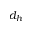<formula> <loc_0><loc_0><loc_500><loc_500>d _ { h }</formula> 